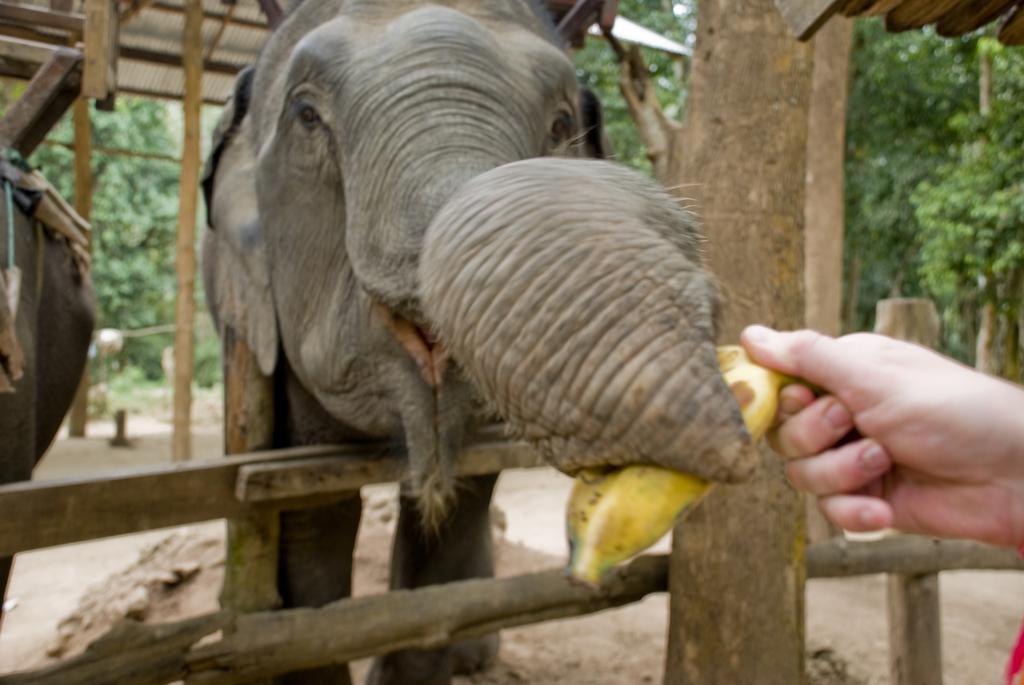How would you summarize this image in a sentence or two? In this picture we can see elephants on the ground, here we can see a fence, person holding a banana and in the background we can see a shed, trees. 